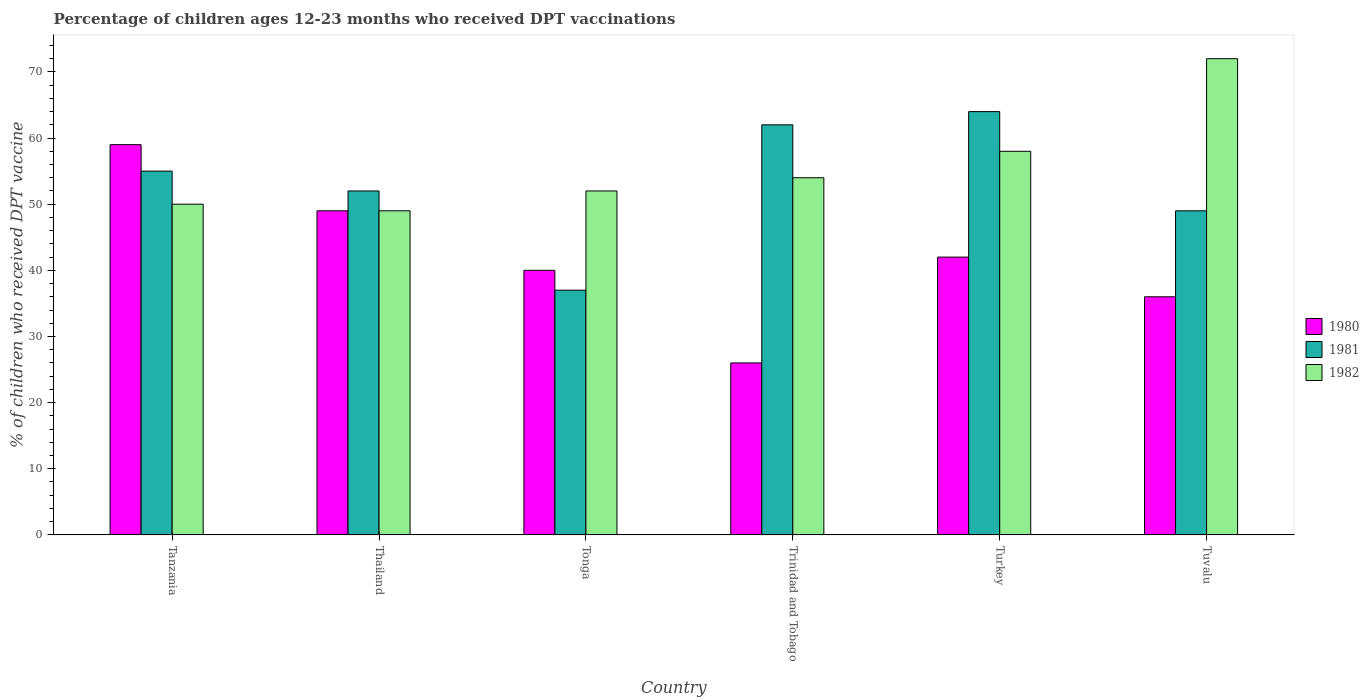Are the number of bars per tick equal to the number of legend labels?
Provide a short and direct response. Yes. Are the number of bars on each tick of the X-axis equal?
Give a very brief answer. Yes. How many bars are there on the 6th tick from the left?
Keep it short and to the point. 3. How many bars are there on the 4th tick from the right?
Provide a short and direct response. 3. What is the label of the 4th group of bars from the left?
Keep it short and to the point. Trinidad and Tobago. In how many cases, is the number of bars for a given country not equal to the number of legend labels?
Give a very brief answer. 0. Across all countries, what is the maximum percentage of children who received DPT vaccination in 1980?
Your response must be concise. 59. Across all countries, what is the minimum percentage of children who received DPT vaccination in 1982?
Offer a terse response. 49. In which country was the percentage of children who received DPT vaccination in 1981 minimum?
Offer a terse response. Tonga. What is the total percentage of children who received DPT vaccination in 1980 in the graph?
Your answer should be very brief. 252. What is the difference between the percentage of children who received DPT vaccination in 1980 in Tonga and that in Turkey?
Offer a very short reply. -2. What is the difference between the percentage of children who received DPT vaccination in 1981 in Tanzania and the percentage of children who received DPT vaccination in 1980 in Tuvalu?
Your answer should be very brief. 19. What is the average percentage of children who received DPT vaccination in 1980 per country?
Your response must be concise. 42. What is the difference between the percentage of children who received DPT vaccination of/in 1981 and percentage of children who received DPT vaccination of/in 1980 in Tonga?
Make the answer very short. -3. In how many countries, is the percentage of children who received DPT vaccination in 1982 greater than 38 %?
Provide a short and direct response. 6. What is the ratio of the percentage of children who received DPT vaccination in 1982 in Thailand to that in Tonga?
Give a very brief answer. 0.94. Is the sum of the percentage of children who received DPT vaccination in 1981 in Tonga and Tuvalu greater than the maximum percentage of children who received DPT vaccination in 1982 across all countries?
Offer a very short reply. Yes. What does the 3rd bar from the left in Thailand represents?
Your response must be concise. 1982. Is it the case that in every country, the sum of the percentage of children who received DPT vaccination in 1981 and percentage of children who received DPT vaccination in 1982 is greater than the percentage of children who received DPT vaccination in 1980?
Keep it short and to the point. Yes. How many bars are there?
Ensure brevity in your answer.  18. Does the graph contain grids?
Ensure brevity in your answer.  No. How many legend labels are there?
Your answer should be compact. 3. How are the legend labels stacked?
Ensure brevity in your answer.  Vertical. What is the title of the graph?
Ensure brevity in your answer.  Percentage of children ages 12-23 months who received DPT vaccinations. What is the label or title of the X-axis?
Give a very brief answer. Country. What is the label or title of the Y-axis?
Provide a succinct answer. % of children who received DPT vaccine. What is the % of children who received DPT vaccine in 1980 in Thailand?
Provide a short and direct response. 49. What is the % of children who received DPT vaccine in 1982 in Thailand?
Offer a very short reply. 49. What is the % of children who received DPT vaccine in 1980 in Tonga?
Keep it short and to the point. 40. What is the % of children who received DPT vaccine in 1982 in Tonga?
Keep it short and to the point. 52. What is the % of children who received DPT vaccine of 1980 in Turkey?
Make the answer very short. 42. Across all countries, what is the maximum % of children who received DPT vaccine in 1980?
Make the answer very short. 59. Across all countries, what is the minimum % of children who received DPT vaccine in 1980?
Your answer should be very brief. 26. Across all countries, what is the minimum % of children who received DPT vaccine in 1981?
Provide a short and direct response. 37. Across all countries, what is the minimum % of children who received DPT vaccine in 1982?
Your answer should be compact. 49. What is the total % of children who received DPT vaccine of 1980 in the graph?
Your answer should be very brief. 252. What is the total % of children who received DPT vaccine in 1981 in the graph?
Keep it short and to the point. 319. What is the total % of children who received DPT vaccine in 1982 in the graph?
Offer a very short reply. 335. What is the difference between the % of children who received DPT vaccine of 1980 in Tanzania and that in Thailand?
Keep it short and to the point. 10. What is the difference between the % of children who received DPT vaccine of 1981 in Tanzania and that in Thailand?
Your answer should be very brief. 3. What is the difference between the % of children who received DPT vaccine of 1980 in Tanzania and that in Trinidad and Tobago?
Your answer should be compact. 33. What is the difference between the % of children who received DPT vaccine in 1981 in Tanzania and that in Trinidad and Tobago?
Offer a terse response. -7. What is the difference between the % of children who received DPT vaccine of 1980 in Tanzania and that in Turkey?
Provide a short and direct response. 17. What is the difference between the % of children who received DPT vaccine in 1981 in Tanzania and that in Turkey?
Give a very brief answer. -9. What is the difference between the % of children who received DPT vaccine of 1982 in Tanzania and that in Turkey?
Keep it short and to the point. -8. What is the difference between the % of children who received DPT vaccine of 1980 in Tanzania and that in Tuvalu?
Your answer should be compact. 23. What is the difference between the % of children who received DPT vaccine in 1980 in Thailand and that in Tonga?
Make the answer very short. 9. What is the difference between the % of children who received DPT vaccine of 1982 in Thailand and that in Tonga?
Your response must be concise. -3. What is the difference between the % of children who received DPT vaccine in 1981 in Thailand and that in Trinidad and Tobago?
Give a very brief answer. -10. What is the difference between the % of children who received DPT vaccine in 1980 in Thailand and that in Turkey?
Give a very brief answer. 7. What is the difference between the % of children who received DPT vaccine of 1982 in Thailand and that in Turkey?
Make the answer very short. -9. What is the difference between the % of children who received DPT vaccine in 1980 in Thailand and that in Tuvalu?
Your response must be concise. 13. What is the difference between the % of children who received DPT vaccine of 1981 in Thailand and that in Tuvalu?
Provide a succinct answer. 3. What is the difference between the % of children who received DPT vaccine in 1980 in Tonga and that in Trinidad and Tobago?
Your response must be concise. 14. What is the difference between the % of children who received DPT vaccine of 1981 in Tonga and that in Trinidad and Tobago?
Give a very brief answer. -25. What is the difference between the % of children who received DPT vaccine of 1980 in Tonga and that in Turkey?
Offer a terse response. -2. What is the difference between the % of children who received DPT vaccine of 1981 in Tonga and that in Turkey?
Provide a short and direct response. -27. What is the difference between the % of children who received DPT vaccine of 1982 in Tonga and that in Turkey?
Make the answer very short. -6. What is the difference between the % of children who received DPT vaccine in 1980 in Trinidad and Tobago and that in Turkey?
Ensure brevity in your answer.  -16. What is the difference between the % of children who received DPT vaccine in 1981 in Trinidad and Tobago and that in Turkey?
Give a very brief answer. -2. What is the difference between the % of children who received DPT vaccine in 1981 in Trinidad and Tobago and that in Tuvalu?
Offer a terse response. 13. What is the difference between the % of children who received DPT vaccine of 1980 in Turkey and that in Tuvalu?
Your response must be concise. 6. What is the difference between the % of children who received DPT vaccine in 1981 in Turkey and that in Tuvalu?
Your answer should be compact. 15. What is the difference between the % of children who received DPT vaccine in 1980 in Tanzania and the % of children who received DPT vaccine in 1981 in Thailand?
Provide a succinct answer. 7. What is the difference between the % of children who received DPT vaccine in 1980 in Tanzania and the % of children who received DPT vaccine in 1982 in Tonga?
Your answer should be compact. 7. What is the difference between the % of children who received DPT vaccine in 1980 in Tanzania and the % of children who received DPT vaccine in 1982 in Trinidad and Tobago?
Give a very brief answer. 5. What is the difference between the % of children who received DPT vaccine in 1981 in Tanzania and the % of children who received DPT vaccine in 1982 in Trinidad and Tobago?
Your answer should be compact. 1. What is the difference between the % of children who received DPT vaccine in 1980 in Tanzania and the % of children who received DPT vaccine in 1982 in Tuvalu?
Make the answer very short. -13. What is the difference between the % of children who received DPT vaccine in 1981 in Tanzania and the % of children who received DPT vaccine in 1982 in Tuvalu?
Provide a succinct answer. -17. What is the difference between the % of children who received DPT vaccine in 1980 in Thailand and the % of children who received DPT vaccine in 1981 in Tonga?
Your answer should be very brief. 12. What is the difference between the % of children who received DPT vaccine in 1980 in Thailand and the % of children who received DPT vaccine in 1982 in Tonga?
Your answer should be very brief. -3. What is the difference between the % of children who received DPT vaccine of 1981 in Thailand and the % of children who received DPT vaccine of 1982 in Tonga?
Keep it short and to the point. 0. What is the difference between the % of children who received DPT vaccine in 1980 in Thailand and the % of children who received DPT vaccine in 1981 in Trinidad and Tobago?
Keep it short and to the point. -13. What is the difference between the % of children who received DPT vaccine of 1980 in Thailand and the % of children who received DPT vaccine of 1981 in Turkey?
Keep it short and to the point. -15. What is the difference between the % of children who received DPT vaccine in 1981 in Thailand and the % of children who received DPT vaccine in 1982 in Turkey?
Provide a succinct answer. -6. What is the difference between the % of children who received DPT vaccine of 1981 in Tonga and the % of children who received DPT vaccine of 1982 in Trinidad and Tobago?
Your response must be concise. -17. What is the difference between the % of children who received DPT vaccine of 1980 in Tonga and the % of children who received DPT vaccine of 1982 in Turkey?
Provide a short and direct response. -18. What is the difference between the % of children who received DPT vaccine of 1981 in Tonga and the % of children who received DPT vaccine of 1982 in Turkey?
Provide a succinct answer. -21. What is the difference between the % of children who received DPT vaccine in 1980 in Tonga and the % of children who received DPT vaccine in 1981 in Tuvalu?
Your response must be concise. -9. What is the difference between the % of children who received DPT vaccine of 1980 in Tonga and the % of children who received DPT vaccine of 1982 in Tuvalu?
Offer a terse response. -32. What is the difference between the % of children who received DPT vaccine of 1981 in Tonga and the % of children who received DPT vaccine of 1982 in Tuvalu?
Make the answer very short. -35. What is the difference between the % of children who received DPT vaccine of 1980 in Trinidad and Tobago and the % of children who received DPT vaccine of 1981 in Turkey?
Your response must be concise. -38. What is the difference between the % of children who received DPT vaccine of 1980 in Trinidad and Tobago and the % of children who received DPT vaccine of 1982 in Turkey?
Keep it short and to the point. -32. What is the difference between the % of children who received DPT vaccine in 1981 in Trinidad and Tobago and the % of children who received DPT vaccine in 1982 in Turkey?
Make the answer very short. 4. What is the difference between the % of children who received DPT vaccine in 1980 in Trinidad and Tobago and the % of children who received DPT vaccine in 1982 in Tuvalu?
Give a very brief answer. -46. What is the difference between the % of children who received DPT vaccine of 1981 in Trinidad and Tobago and the % of children who received DPT vaccine of 1982 in Tuvalu?
Make the answer very short. -10. What is the difference between the % of children who received DPT vaccine of 1980 in Turkey and the % of children who received DPT vaccine of 1981 in Tuvalu?
Your answer should be compact. -7. What is the average % of children who received DPT vaccine in 1981 per country?
Offer a very short reply. 53.17. What is the average % of children who received DPT vaccine of 1982 per country?
Offer a terse response. 55.83. What is the difference between the % of children who received DPT vaccine in 1980 and % of children who received DPT vaccine in 1981 in Tanzania?
Keep it short and to the point. 4. What is the difference between the % of children who received DPT vaccine in 1980 and % of children who received DPT vaccine in 1982 in Tanzania?
Keep it short and to the point. 9. What is the difference between the % of children who received DPT vaccine in 1981 and % of children who received DPT vaccine in 1982 in Tanzania?
Provide a succinct answer. 5. What is the difference between the % of children who received DPT vaccine in 1980 and % of children who received DPT vaccine in 1981 in Thailand?
Ensure brevity in your answer.  -3. What is the difference between the % of children who received DPT vaccine of 1981 and % of children who received DPT vaccine of 1982 in Thailand?
Offer a terse response. 3. What is the difference between the % of children who received DPT vaccine of 1980 and % of children who received DPT vaccine of 1981 in Tonga?
Ensure brevity in your answer.  3. What is the difference between the % of children who received DPT vaccine in 1980 and % of children who received DPT vaccine in 1981 in Trinidad and Tobago?
Provide a short and direct response. -36. What is the difference between the % of children who received DPT vaccine of 1981 and % of children who received DPT vaccine of 1982 in Trinidad and Tobago?
Ensure brevity in your answer.  8. What is the difference between the % of children who received DPT vaccine of 1980 and % of children who received DPT vaccine of 1981 in Tuvalu?
Make the answer very short. -13. What is the difference between the % of children who received DPT vaccine of 1980 and % of children who received DPT vaccine of 1982 in Tuvalu?
Offer a terse response. -36. What is the ratio of the % of children who received DPT vaccine in 1980 in Tanzania to that in Thailand?
Your answer should be very brief. 1.2. What is the ratio of the % of children who received DPT vaccine in 1981 in Tanzania to that in Thailand?
Ensure brevity in your answer.  1.06. What is the ratio of the % of children who received DPT vaccine of 1982 in Tanzania to that in Thailand?
Offer a very short reply. 1.02. What is the ratio of the % of children who received DPT vaccine in 1980 in Tanzania to that in Tonga?
Provide a short and direct response. 1.48. What is the ratio of the % of children who received DPT vaccine in 1981 in Tanzania to that in Tonga?
Your answer should be compact. 1.49. What is the ratio of the % of children who received DPT vaccine in 1982 in Tanzania to that in Tonga?
Offer a very short reply. 0.96. What is the ratio of the % of children who received DPT vaccine of 1980 in Tanzania to that in Trinidad and Tobago?
Your answer should be compact. 2.27. What is the ratio of the % of children who received DPT vaccine in 1981 in Tanzania to that in Trinidad and Tobago?
Provide a succinct answer. 0.89. What is the ratio of the % of children who received DPT vaccine in 1982 in Tanzania to that in Trinidad and Tobago?
Offer a terse response. 0.93. What is the ratio of the % of children who received DPT vaccine in 1980 in Tanzania to that in Turkey?
Provide a succinct answer. 1.4. What is the ratio of the % of children who received DPT vaccine in 1981 in Tanzania to that in Turkey?
Provide a succinct answer. 0.86. What is the ratio of the % of children who received DPT vaccine in 1982 in Tanzania to that in Turkey?
Ensure brevity in your answer.  0.86. What is the ratio of the % of children who received DPT vaccine of 1980 in Tanzania to that in Tuvalu?
Provide a succinct answer. 1.64. What is the ratio of the % of children who received DPT vaccine of 1981 in Tanzania to that in Tuvalu?
Your answer should be very brief. 1.12. What is the ratio of the % of children who received DPT vaccine in 1982 in Tanzania to that in Tuvalu?
Make the answer very short. 0.69. What is the ratio of the % of children who received DPT vaccine in 1980 in Thailand to that in Tonga?
Ensure brevity in your answer.  1.23. What is the ratio of the % of children who received DPT vaccine in 1981 in Thailand to that in Tonga?
Offer a terse response. 1.41. What is the ratio of the % of children who received DPT vaccine of 1982 in Thailand to that in Tonga?
Your response must be concise. 0.94. What is the ratio of the % of children who received DPT vaccine in 1980 in Thailand to that in Trinidad and Tobago?
Keep it short and to the point. 1.88. What is the ratio of the % of children who received DPT vaccine in 1981 in Thailand to that in Trinidad and Tobago?
Your answer should be very brief. 0.84. What is the ratio of the % of children who received DPT vaccine in 1982 in Thailand to that in Trinidad and Tobago?
Your response must be concise. 0.91. What is the ratio of the % of children who received DPT vaccine in 1981 in Thailand to that in Turkey?
Offer a terse response. 0.81. What is the ratio of the % of children who received DPT vaccine of 1982 in Thailand to that in Turkey?
Provide a succinct answer. 0.84. What is the ratio of the % of children who received DPT vaccine of 1980 in Thailand to that in Tuvalu?
Your answer should be very brief. 1.36. What is the ratio of the % of children who received DPT vaccine of 1981 in Thailand to that in Tuvalu?
Make the answer very short. 1.06. What is the ratio of the % of children who received DPT vaccine of 1982 in Thailand to that in Tuvalu?
Keep it short and to the point. 0.68. What is the ratio of the % of children who received DPT vaccine in 1980 in Tonga to that in Trinidad and Tobago?
Make the answer very short. 1.54. What is the ratio of the % of children who received DPT vaccine of 1981 in Tonga to that in Trinidad and Tobago?
Your answer should be compact. 0.6. What is the ratio of the % of children who received DPT vaccine in 1982 in Tonga to that in Trinidad and Tobago?
Provide a succinct answer. 0.96. What is the ratio of the % of children who received DPT vaccine in 1981 in Tonga to that in Turkey?
Make the answer very short. 0.58. What is the ratio of the % of children who received DPT vaccine in 1982 in Tonga to that in Turkey?
Offer a very short reply. 0.9. What is the ratio of the % of children who received DPT vaccine in 1980 in Tonga to that in Tuvalu?
Give a very brief answer. 1.11. What is the ratio of the % of children who received DPT vaccine in 1981 in Tonga to that in Tuvalu?
Your response must be concise. 0.76. What is the ratio of the % of children who received DPT vaccine of 1982 in Tonga to that in Tuvalu?
Your response must be concise. 0.72. What is the ratio of the % of children who received DPT vaccine of 1980 in Trinidad and Tobago to that in Turkey?
Give a very brief answer. 0.62. What is the ratio of the % of children who received DPT vaccine of 1981 in Trinidad and Tobago to that in Turkey?
Offer a very short reply. 0.97. What is the ratio of the % of children who received DPT vaccine of 1980 in Trinidad and Tobago to that in Tuvalu?
Your response must be concise. 0.72. What is the ratio of the % of children who received DPT vaccine of 1981 in Trinidad and Tobago to that in Tuvalu?
Your response must be concise. 1.27. What is the ratio of the % of children who received DPT vaccine of 1982 in Trinidad and Tobago to that in Tuvalu?
Give a very brief answer. 0.75. What is the ratio of the % of children who received DPT vaccine in 1980 in Turkey to that in Tuvalu?
Your answer should be very brief. 1.17. What is the ratio of the % of children who received DPT vaccine of 1981 in Turkey to that in Tuvalu?
Keep it short and to the point. 1.31. What is the ratio of the % of children who received DPT vaccine of 1982 in Turkey to that in Tuvalu?
Keep it short and to the point. 0.81. What is the difference between the highest and the second highest % of children who received DPT vaccine in 1980?
Ensure brevity in your answer.  10. What is the difference between the highest and the second highest % of children who received DPT vaccine of 1982?
Give a very brief answer. 14. What is the difference between the highest and the lowest % of children who received DPT vaccine of 1980?
Give a very brief answer. 33. 